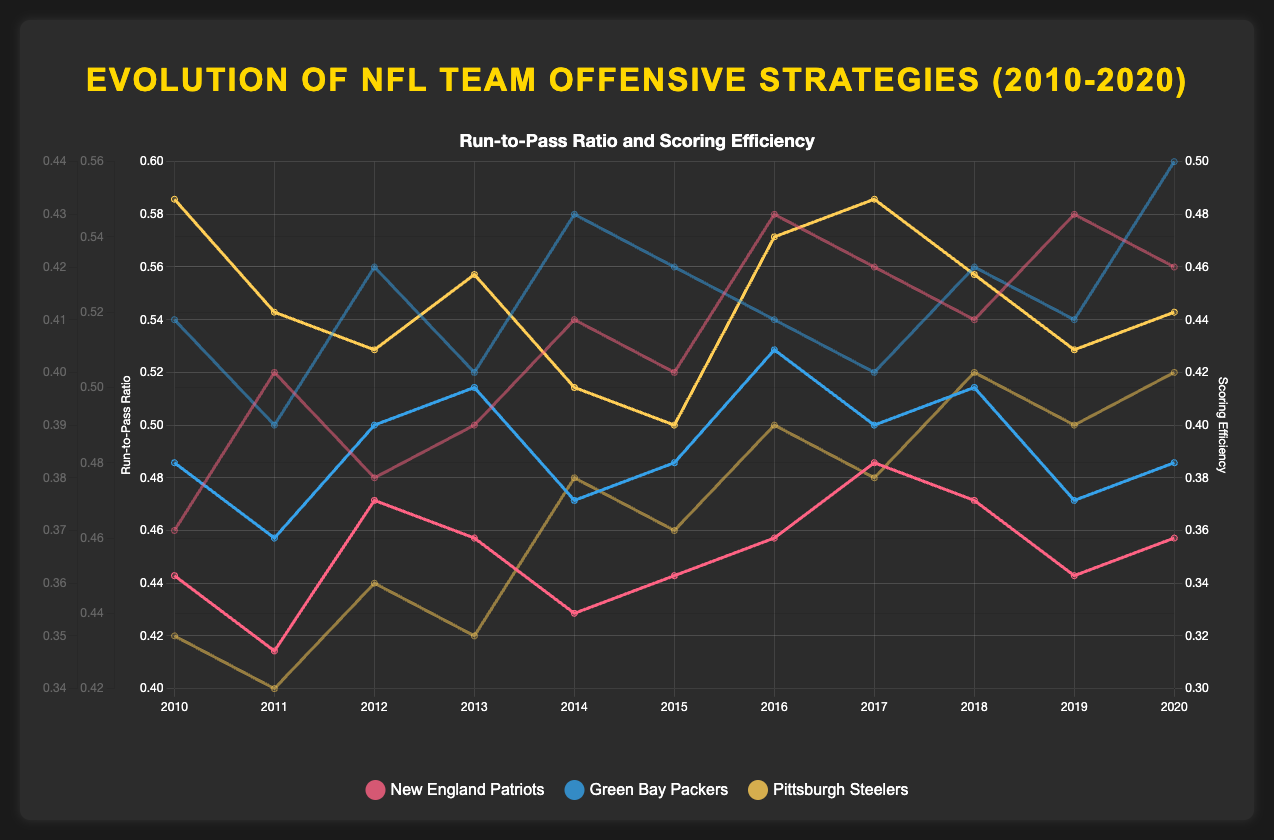What trend is observed in the run-to-pass ratio of the New England Patriots from 2010 to 2020? To determine the trend, observe the line representing the New England Patriots' run-to-pass ratio over the years. It fluctuates around 0.45 to 0.48 with some minor variations but overall remains relatively stable.
Answer: Relatively stable Which team had the highest scoring efficiency in 2016? Locate the year 2016 and identify the team with the highest value on the right-side y-axis (scoring efficiency) among the three lines representing scoring efficiency. The New England Patriots have the highest efficiency just above 0.43.
Answer: New England Patriots Compare the run-to-pass ratios of the Green Bay Packers and Pittsburgh Steelers in 2014. Which team had a higher ratio, and by how much? Look at the run-to-pass ratios for both teams in 2014. The Packers have a ratio of 0.47, and the Steelers have 0.50. Calculate the difference: 0.50 - 0.47 = 0.03.
Answer: Pittsburgh Steelers, 0.03 Did any team have a scoring efficiency of 0.40 in 2015? Check the scoring efficiency values for each team in 2015. The New England Patriots had a scoring efficiency of 0.40.
Answer: New England Patriots Calculate the average scoring efficiency of the Pittsburgh Steelers from 2010 to 2020. Sum the scoring efficiencies for each year (0.35 + 0.34 + 0.36 + 0.35 + 0.38 + 0.37 + 0.39 + 0.38 + 0.40 + 0.39 + 0.40) and then divide by the number of years (11). The total is 4.01, the average is 4.01 / 11 ≈ 0.3645.
Answer: ≈ 0.3645 What is the relationship between run-to-pass ratio and scoring efficiency for the New England Patriots in 2020? For 2020, observe the values: run-to-pass ratio is 0.46, and scoring efficiency is 0.42. Comment on the relationship by noting that scoring efficiency seems relatively high with a balanced run-to-pass ratio.
Answer: Balanced ratio, high efficiency Which team showed the most consistent run-to-pass ratio from 2010 to 2020? Identify which team's line for run-to-pass ratio shows the least fluctuation over the years. The New England Patriots show relatively stable variation compared to the other teams.
Answer: New England Patriots In which year did the Green Bay Packers achieve their highest scoring efficiency, and what was the value? Locate the peak of the Green Bay Packers' scoring efficiency line and match it to the corresponding year on the x-axis. The peak occurs in 2020, with a value of 0.44.
Answer: 2020, 0.44 